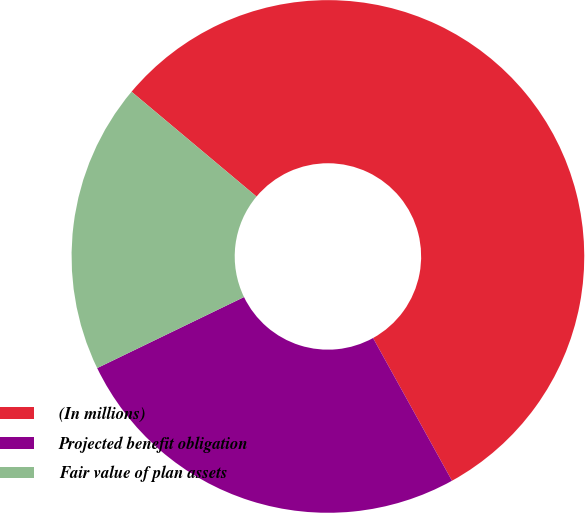Convert chart to OTSL. <chart><loc_0><loc_0><loc_500><loc_500><pie_chart><fcel>(In millions)<fcel>Projected benefit obligation<fcel>Fair value of plan assets<nl><fcel>55.85%<fcel>25.87%<fcel>18.28%<nl></chart> 